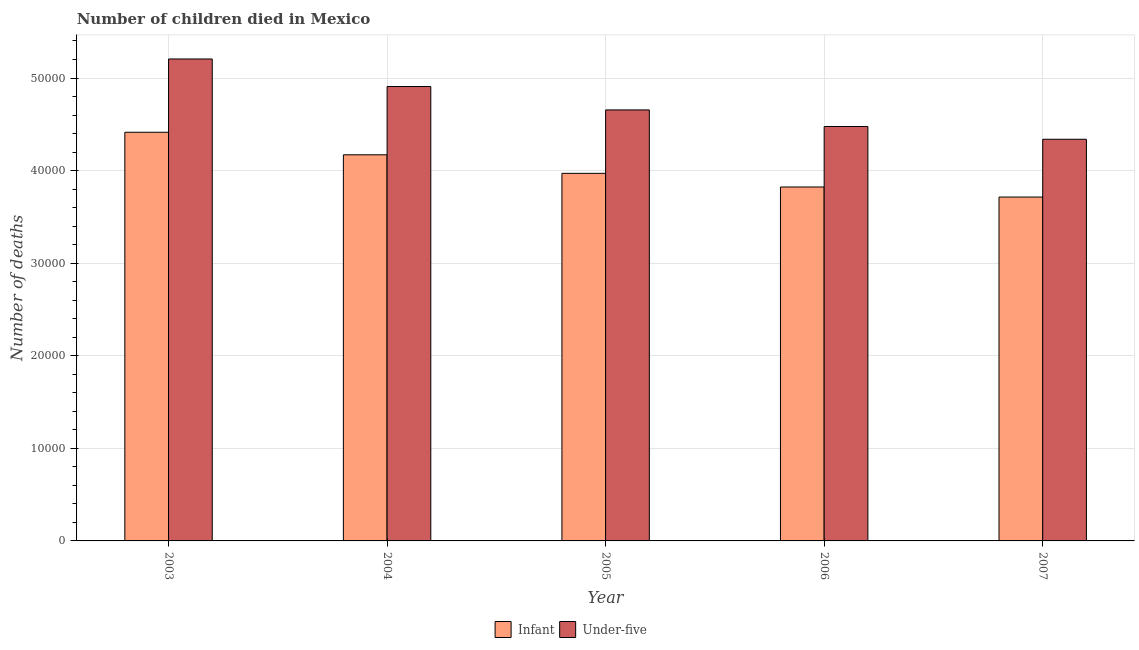How many groups of bars are there?
Give a very brief answer. 5. How many bars are there on the 5th tick from the left?
Provide a short and direct response. 2. How many bars are there on the 3rd tick from the right?
Provide a short and direct response. 2. In how many cases, is the number of bars for a given year not equal to the number of legend labels?
Provide a succinct answer. 0. What is the number of infant deaths in 2004?
Offer a terse response. 4.17e+04. Across all years, what is the maximum number of under-five deaths?
Offer a very short reply. 5.21e+04. Across all years, what is the minimum number of under-five deaths?
Your answer should be compact. 4.34e+04. In which year was the number of under-five deaths maximum?
Provide a succinct answer. 2003. What is the total number of under-five deaths in the graph?
Provide a succinct answer. 2.36e+05. What is the difference between the number of under-five deaths in 2004 and that in 2007?
Your answer should be very brief. 5696. What is the difference between the number of infant deaths in 2005 and the number of under-five deaths in 2006?
Offer a very short reply. 1474. What is the average number of under-five deaths per year?
Provide a succinct answer. 4.72e+04. In how many years, is the number of infant deaths greater than 12000?
Provide a succinct answer. 5. What is the ratio of the number of under-five deaths in 2003 to that in 2007?
Provide a short and direct response. 1.2. Is the number of infant deaths in 2004 less than that in 2007?
Offer a very short reply. No. Is the difference between the number of under-five deaths in 2004 and 2006 greater than the difference between the number of infant deaths in 2004 and 2006?
Your response must be concise. No. What is the difference between the highest and the second highest number of under-five deaths?
Your answer should be compact. 2975. What is the difference between the highest and the lowest number of under-five deaths?
Offer a terse response. 8671. In how many years, is the number of infant deaths greater than the average number of infant deaths taken over all years?
Your response must be concise. 2. Is the sum of the number of under-five deaths in 2004 and 2007 greater than the maximum number of infant deaths across all years?
Offer a very short reply. Yes. What does the 2nd bar from the left in 2005 represents?
Offer a very short reply. Under-five. What does the 1st bar from the right in 2004 represents?
Keep it short and to the point. Under-five. How many years are there in the graph?
Offer a terse response. 5. Are the values on the major ticks of Y-axis written in scientific E-notation?
Make the answer very short. No. Does the graph contain grids?
Offer a very short reply. Yes. What is the title of the graph?
Your answer should be compact. Number of children died in Mexico. Does "Forest" appear as one of the legend labels in the graph?
Keep it short and to the point. No. What is the label or title of the Y-axis?
Make the answer very short. Number of deaths. What is the Number of deaths of Infant in 2003?
Keep it short and to the point. 4.41e+04. What is the Number of deaths in Under-five in 2003?
Offer a very short reply. 5.21e+04. What is the Number of deaths of Infant in 2004?
Your answer should be very brief. 4.17e+04. What is the Number of deaths of Under-five in 2004?
Provide a short and direct response. 4.91e+04. What is the Number of deaths in Infant in 2005?
Provide a succinct answer. 3.97e+04. What is the Number of deaths of Under-five in 2005?
Provide a succinct answer. 4.66e+04. What is the Number of deaths in Infant in 2006?
Keep it short and to the point. 3.82e+04. What is the Number of deaths in Under-five in 2006?
Offer a terse response. 4.48e+04. What is the Number of deaths of Infant in 2007?
Make the answer very short. 3.71e+04. What is the Number of deaths of Under-five in 2007?
Keep it short and to the point. 4.34e+04. Across all years, what is the maximum Number of deaths of Infant?
Keep it short and to the point. 4.41e+04. Across all years, what is the maximum Number of deaths in Under-five?
Your response must be concise. 5.21e+04. Across all years, what is the minimum Number of deaths in Infant?
Keep it short and to the point. 3.71e+04. Across all years, what is the minimum Number of deaths in Under-five?
Keep it short and to the point. 4.34e+04. What is the total Number of deaths of Infant in the graph?
Your response must be concise. 2.01e+05. What is the total Number of deaths of Under-five in the graph?
Your response must be concise. 2.36e+05. What is the difference between the Number of deaths in Infant in 2003 and that in 2004?
Ensure brevity in your answer.  2435. What is the difference between the Number of deaths in Under-five in 2003 and that in 2004?
Make the answer very short. 2975. What is the difference between the Number of deaths in Infant in 2003 and that in 2005?
Your answer should be very brief. 4437. What is the difference between the Number of deaths of Under-five in 2003 and that in 2005?
Ensure brevity in your answer.  5503. What is the difference between the Number of deaths of Infant in 2003 and that in 2006?
Your response must be concise. 5911. What is the difference between the Number of deaths of Under-five in 2003 and that in 2006?
Offer a terse response. 7293. What is the difference between the Number of deaths in Infant in 2003 and that in 2007?
Your answer should be very brief. 6999. What is the difference between the Number of deaths of Under-five in 2003 and that in 2007?
Your response must be concise. 8671. What is the difference between the Number of deaths of Infant in 2004 and that in 2005?
Provide a short and direct response. 2002. What is the difference between the Number of deaths in Under-five in 2004 and that in 2005?
Your response must be concise. 2528. What is the difference between the Number of deaths in Infant in 2004 and that in 2006?
Provide a succinct answer. 3476. What is the difference between the Number of deaths of Under-five in 2004 and that in 2006?
Provide a short and direct response. 4318. What is the difference between the Number of deaths of Infant in 2004 and that in 2007?
Offer a very short reply. 4564. What is the difference between the Number of deaths in Under-five in 2004 and that in 2007?
Ensure brevity in your answer.  5696. What is the difference between the Number of deaths of Infant in 2005 and that in 2006?
Provide a succinct answer. 1474. What is the difference between the Number of deaths in Under-five in 2005 and that in 2006?
Your answer should be very brief. 1790. What is the difference between the Number of deaths of Infant in 2005 and that in 2007?
Provide a succinct answer. 2562. What is the difference between the Number of deaths in Under-five in 2005 and that in 2007?
Offer a terse response. 3168. What is the difference between the Number of deaths in Infant in 2006 and that in 2007?
Make the answer very short. 1088. What is the difference between the Number of deaths of Under-five in 2006 and that in 2007?
Offer a terse response. 1378. What is the difference between the Number of deaths of Infant in 2003 and the Number of deaths of Under-five in 2004?
Keep it short and to the point. -4941. What is the difference between the Number of deaths of Infant in 2003 and the Number of deaths of Under-five in 2005?
Provide a succinct answer. -2413. What is the difference between the Number of deaths in Infant in 2003 and the Number of deaths in Under-five in 2006?
Give a very brief answer. -623. What is the difference between the Number of deaths of Infant in 2003 and the Number of deaths of Under-five in 2007?
Your answer should be very brief. 755. What is the difference between the Number of deaths of Infant in 2004 and the Number of deaths of Under-five in 2005?
Keep it short and to the point. -4848. What is the difference between the Number of deaths in Infant in 2004 and the Number of deaths in Under-five in 2006?
Your response must be concise. -3058. What is the difference between the Number of deaths of Infant in 2004 and the Number of deaths of Under-five in 2007?
Offer a terse response. -1680. What is the difference between the Number of deaths of Infant in 2005 and the Number of deaths of Under-five in 2006?
Give a very brief answer. -5060. What is the difference between the Number of deaths in Infant in 2005 and the Number of deaths in Under-five in 2007?
Provide a short and direct response. -3682. What is the difference between the Number of deaths in Infant in 2006 and the Number of deaths in Under-five in 2007?
Your answer should be compact. -5156. What is the average Number of deaths in Infant per year?
Make the answer very short. 4.02e+04. What is the average Number of deaths of Under-five per year?
Ensure brevity in your answer.  4.72e+04. In the year 2003, what is the difference between the Number of deaths in Infant and Number of deaths in Under-five?
Keep it short and to the point. -7916. In the year 2004, what is the difference between the Number of deaths in Infant and Number of deaths in Under-five?
Give a very brief answer. -7376. In the year 2005, what is the difference between the Number of deaths in Infant and Number of deaths in Under-five?
Provide a short and direct response. -6850. In the year 2006, what is the difference between the Number of deaths in Infant and Number of deaths in Under-five?
Offer a very short reply. -6534. In the year 2007, what is the difference between the Number of deaths of Infant and Number of deaths of Under-five?
Ensure brevity in your answer.  -6244. What is the ratio of the Number of deaths of Infant in 2003 to that in 2004?
Make the answer very short. 1.06. What is the ratio of the Number of deaths in Under-five in 2003 to that in 2004?
Your answer should be very brief. 1.06. What is the ratio of the Number of deaths in Infant in 2003 to that in 2005?
Provide a short and direct response. 1.11. What is the ratio of the Number of deaths of Under-five in 2003 to that in 2005?
Offer a very short reply. 1.12. What is the ratio of the Number of deaths in Infant in 2003 to that in 2006?
Give a very brief answer. 1.15. What is the ratio of the Number of deaths of Under-five in 2003 to that in 2006?
Your answer should be compact. 1.16. What is the ratio of the Number of deaths of Infant in 2003 to that in 2007?
Your answer should be compact. 1.19. What is the ratio of the Number of deaths of Under-five in 2003 to that in 2007?
Offer a terse response. 1.2. What is the ratio of the Number of deaths of Infant in 2004 to that in 2005?
Offer a terse response. 1.05. What is the ratio of the Number of deaths in Under-five in 2004 to that in 2005?
Offer a very short reply. 1.05. What is the ratio of the Number of deaths in Infant in 2004 to that in 2006?
Your answer should be compact. 1.09. What is the ratio of the Number of deaths of Under-five in 2004 to that in 2006?
Your answer should be compact. 1.1. What is the ratio of the Number of deaths in Infant in 2004 to that in 2007?
Offer a terse response. 1.12. What is the ratio of the Number of deaths of Under-five in 2004 to that in 2007?
Your answer should be very brief. 1.13. What is the ratio of the Number of deaths of Infant in 2005 to that in 2006?
Make the answer very short. 1.04. What is the ratio of the Number of deaths in Infant in 2005 to that in 2007?
Provide a short and direct response. 1.07. What is the ratio of the Number of deaths of Under-five in 2005 to that in 2007?
Ensure brevity in your answer.  1.07. What is the ratio of the Number of deaths of Infant in 2006 to that in 2007?
Offer a very short reply. 1.03. What is the ratio of the Number of deaths in Under-five in 2006 to that in 2007?
Offer a terse response. 1.03. What is the difference between the highest and the second highest Number of deaths in Infant?
Your answer should be compact. 2435. What is the difference between the highest and the second highest Number of deaths of Under-five?
Your answer should be compact. 2975. What is the difference between the highest and the lowest Number of deaths in Infant?
Ensure brevity in your answer.  6999. What is the difference between the highest and the lowest Number of deaths in Under-five?
Keep it short and to the point. 8671. 